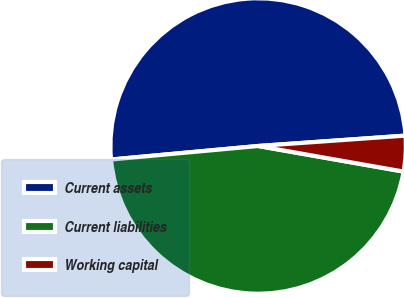Convert chart to OTSL. <chart><loc_0><loc_0><loc_500><loc_500><pie_chart><fcel>Current assets<fcel>Current liabilities<fcel>Working capital<nl><fcel>50.34%<fcel>45.77%<fcel>3.89%<nl></chart> 